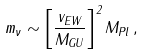Convert formula to latex. <formula><loc_0><loc_0><loc_500><loc_500>m _ { \nu } \sim \left [ \frac { v _ { E W } } { M _ { G U } } \right ] ^ { 2 } M _ { P l } \, ,</formula> 